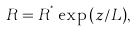Convert formula to latex. <formula><loc_0><loc_0><loc_500><loc_500>R = R ^ { ^ { * } } \exp { ( z / L ) } ,</formula> 